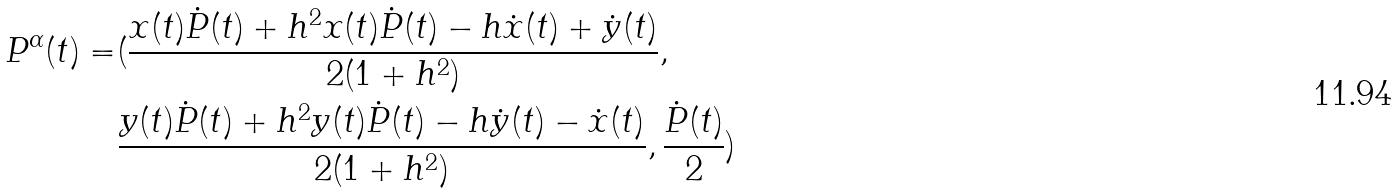<formula> <loc_0><loc_0><loc_500><loc_500>P ^ { \alpha } ( t ) = & ( \frac { x ( t ) \dot { P } ( t ) + h ^ { 2 } x ( t ) \dot { P } ( t ) - h \dot { x } ( t ) + \dot { y } ( t ) } { 2 ( 1 + h ^ { 2 } ) } , \\ & \frac { y ( t ) \dot { P } ( t ) + h ^ { 2 } y ( t ) \dot { P } ( t ) - h \dot { y } ( t ) - \dot { x } ( t ) } { 2 ( 1 + h ^ { 2 } ) } , \frac { \dot { P } ( t ) } { 2 } )</formula> 